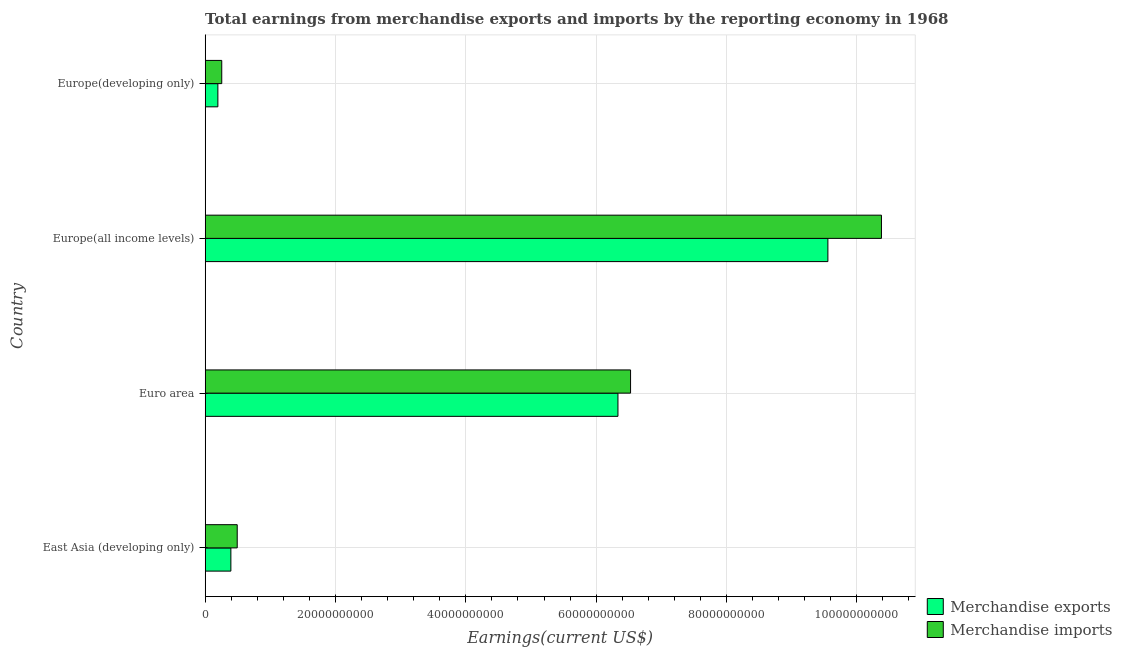Are the number of bars per tick equal to the number of legend labels?
Your answer should be very brief. Yes. Are the number of bars on each tick of the Y-axis equal?
Make the answer very short. Yes. How many bars are there on the 1st tick from the top?
Your answer should be compact. 2. What is the label of the 1st group of bars from the top?
Give a very brief answer. Europe(developing only). What is the earnings from merchandise imports in Euro area?
Offer a very short reply. 6.53e+1. Across all countries, what is the maximum earnings from merchandise exports?
Provide a succinct answer. 9.56e+1. Across all countries, what is the minimum earnings from merchandise imports?
Offer a terse response. 2.54e+09. In which country was the earnings from merchandise exports maximum?
Offer a terse response. Europe(all income levels). In which country was the earnings from merchandise exports minimum?
Your answer should be compact. Europe(developing only). What is the total earnings from merchandise imports in the graph?
Offer a very short reply. 1.77e+11. What is the difference between the earnings from merchandise exports in East Asia (developing only) and that in Europe(all income levels)?
Your answer should be very brief. -9.16e+1. What is the difference between the earnings from merchandise imports in Europe(developing only) and the earnings from merchandise exports in East Asia (developing only)?
Your answer should be compact. -1.40e+09. What is the average earnings from merchandise imports per country?
Keep it short and to the point. 4.41e+1. What is the difference between the earnings from merchandise imports and earnings from merchandise exports in Europe(all income levels)?
Provide a short and direct response. 8.22e+09. In how many countries, is the earnings from merchandise exports greater than 32000000000 US$?
Ensure brevity in your answer.  2. What is the ratio of the earnings from merchandise imports in Euro area to that in Europe(all income levels)?
Provide a short and direct response. 0.63. Is the difference between the earnings from merchandise imports in East Asia (developing only) and Europe(all income levels) greater than the difference between the earnings from merchandise exports in East Asia (developing only) and Europe(all income levels)?
Keep it short and to the point. No. What is the difference between the highest and the second highest earnings from merchandise exports?
Give a very brief answer. 3.22e+1. What is the difference between the highest and the lowest earnings from merchandise exports?
Your answer should be compact. 9.36e+1. Is the sum of the earnings from merchandise exports in Euro area and Europe(developing only) greater than the maximum earnings from merchandise imports across all countries?
Offer a terse response. No. How many bars are there?
Give a very brief answer. 8. Are all the bars in the graph horizontal?
Offer a terse response. Yes. How many legend labels are there?
Offer a terse response. 2. What is the title of the graph?
Keep it short and to the point. Total earnings from merchandise exports and imports by the reporting economy in 1968. Does "Grants" appear as one of the legend labels in the graph?
Ensure brevity in your answer.  No. What is the label or title of the X-axis?
Ensure brevity in your answer.  Earnings(current US$). What is the label or title of the Y-axis?
Make the answer very short. Country. What is the Earnings(current US$) in Merchandise exports in East Asia (developing only)?
Your response must be concise. 3.94e+09. What is the Earnings(current US$) of Merchandise imports in East Asia (developing only)?
Keep it short and to the point. 4.91e+09. What is the Earnings(current US$) in Merchandise exports in Euro area?
Ensure brevity in your answer.  6.33e+1. What is the Earnings(current US$) of Merchandise imports in Euro area?
Provide a succinct answer. 6.53e+1. What is the Earnings(current US$) in Merchandise exports in Europe(all income levels)?
Your answer should be compact. 9.56e+1. What is the Earnings(current US$) in Merchandise imports in Europe(all income levels)?
Your response must be concise. 1.04e+11. What is the Earnings(current US$) of Merchandise exports in Europe(developing only)?
Offer a very short reply. 1.95e+09. What is the Earnings(current US$) of Merchandise imports in Europe(developing only)?
Give a very brief answer. 2.54e+09. Across all countries, what is the maximum Earnings(current US$) in Merchandise exports?
Ensure brevity in your answer.  9.56e+1. Across all countries, what is the maximum Earnings(current US$) of Merchandise imports?
Your answer should be very brief. 1.04e+11. Across all countries, what is the minimum Earnings(current US$) of Merchandise exports?
Provide a succinct answer. 1.95e+09. Across all countries, what is the minimum Earnings(current US$) in Merchandise imports?
Offer a terse response. 2.54e+09. What is the total Earnings(current US$) of Merchandise exports in the graph?
Give a very brief answer. 1.65e+11. What is the total Earnings(current US$) of Merchandise imports in the graph?
Provide a short and direct response. 1.77e+11. What is the difference between the Earnings(current US$) in Merchandise exports in East Asia (developing only) and that in Euro area?
Make the answer very short. -5.94e+1. What is the difference between the Earnings(current US$) of Merchandise imports in East Asia (developing only) and that in Euro area?
Offer a terse response. -6.04e+1. What is the difference between the Earnings(current US$) of Merchandise exports in East Asia (developing only) and that in Europe(all income levels)?
Provide a short and direct response. -9.16e+1. What is the difference between the Earnings(current US$) in Merchandise imports in East Asia (developing only) and that in Europe(all income levels)?
Your answer should be compact. -9.89e+1. What is the difference between the Earnings(current US$) in Merchandise exports in East Asia (developing only) and that in Europe(developing only)?
Offer a very short reply. 1.99e+09. What is the difference between the Earnings(current US$) of Merchandise imports in East Asia (developing only) and that in Europe(developing only)?
Offer a very short reply. 2.37e+09. What is the difference between the Earnings(current US$) in Merchandise exports in Euro area and that in Europe(all income levels)?
Give a very brief answer. -3.22e+1. What is the difference between the Earnings(current US$) in Merchandise imports in Euro area and that in Europe(all income levels)?
Make the answer very short. -3.85e+1. What is the difference between the Earnings(current US$) in Merchandise exports in Euro area and that in Europe(developing only)?
Your answer should be compact. 6.14e+1. What is the difference between the Earnings(current US$) in Merchandise imports in Euro area and that in Europe(developing only)?
Offer a very short reply. 6.27e+1. What is the difference between the Earnings(current US$) of Merchandise exports in Europe(all income levels) and that in Europe(developing only)?
Keep it short and to the point. 9.36e+1. What is the difference between the Earnings(current US$) in Merchandise imports in Europe(all income levels) and that in Europe(developing only)?
Your response must be concise. 1.01e+11. What is the difference between the Earnings(current US$) of Merchandise exports in East Asia (developing only) and the Earnings(current US$) of Merchandise imports in Euro area?
Provide a succinct answer. -6.13e+1. What is the difference between the Earnings(current US$) of Merchandise exports in East Asia (developing only) and the Earnings(current US$) of Merchandise imports in Europe(all income levels)?
Your answer should be compact. -9.98e+1. What is the difference between the Earnings(current US$) in Merchandise exports in East Asia (developing only) and the Earnings(current US$) in Merchandise imports in Europe(developing only)?
Give a very brief answer. 1.40e+09. What is the difference between the Earnings(current US$) of Merchandise exports in Euro area and the Earnings(current US$) of Merchandise imports in Europe(all income levels)?
Provide a succinct answer. -4.04e+1. What is the difference between the Earnings(current US$) of Merchandise exports in Euro area and the Earnings(current US$) of Merchandise imports in Europe(developing only)?
Offer a very short reply. 6.08e+1. What is the difference between the Earnings(current US$) in Merchandise exports in Europe(all income levels) and the Earnings(current US$) in Merchandise imports in Europe(developing only)?
Your answer should be compact. 9.30e+1. What is the average Earnings(current US$) in Merchandise exports per country?
Your answer should be compact. 4.12e+1. What is the average Earnings(current US$) in Merchandise imports per country?
Make the answer very short. 4.41e+1. What is the difference between the Earnings(current US$) in Merchandise exports and Earnings(current US$) in Merchandise imports in East Asia (developing only)?
Provide a short and direct response. -9.73e+08. What is the difference between the Earnings(current US$) in Merchandise exports and Earnings(current US$) in Merchandise imports in Euro area?
Keep it short and to the point. -1.93e+09. What is the difference between the Earnings(current US$) in Merchandise exports and Earnings(current US$) in Merchandise imports in Europe(all income levels)?
Your response must be concise. -8.22e+09. What is the difference between the Earnings(current US$) in Merchandise exports and Earnings(current US$) in Merchandise imports in Europe(developing only)?
Ensure brevity in your answer.  -5.94e+08. What is the ratio of the Earnings(current US$) in Merchandise exports in East Asia (developing only) to that in Euro area?
Give a very brief answer. 0.06. What is the ratio of the Earnings(current US$) in Merchandise imports in East Asia (developing only) to that in Euro area?
Your response must be concise. 0.08. What is the ratio of the Earnings(current US$) of Merchandise exports in East Asia (developing only) to that in Europe(all income levels)?
Your answer should be very brief. 0.04. What is the ratio of the Earnings(current US$) of Merchandise imports in East Asia (developing only) to that in Europe(all income levels)?
Your answer should be compact. 0.05. What is the ratio of the Earnings(current US$) of Merchandise exports in East Asia (developing only) to that in Europe(developing only)?
Give a very brief answer. 2.02. What is the ratio of the Earnings(current US$) in Merchandise imports in East Asia (developing only) to that in Europe(developing only)?
Keep it short and to the point. 1.93. What is the ratio of the Earnings(current US$) of Merchandise exports in Euro area to that in Europe(all income levels)?
Give a very brief answer. 0.66. What is the ratio of the Earnings(current US$) in Merchandise imports in Euro area to that in Europe(all income levels)?
Your response must be concise. 0.63. What is the ratio of the Earnings(current US$) of Merchandise exports in Euro area to that in Europe(developing only)?
Your response must be concise. 32.54. What is the ratio of the Earnings(current US$) of Merchandise imports in Euro area to that in Europe(developing only)?
Your answer should be compact. 25.69. What is the ratio of the Earnings(current US$) in Merchandise exports in Europe(all income levels) to that in Europe(developing only)?
Your response must be concise. 49.08. What is the ratio of the Earnings(current US$) in Merchandise imports in Europe(all income levels) to that in Europe(developing only)?
Make the answer very short. 40.85. What is the difference between the highest and the second highest Earnings(current US$) in Merchandise exports?
Make the answer very short. 3.22e+1. What is the difference between the highest and the second highest Earnings(current US$) in Merchandise imports?
Provide a succinct answer. 3.85e+1. What is the difference between the highest and the lowest Earnings(current US$) in Merchandise exports?
Offer a very short reply. 9.36e+1. What is the difference between the highest and the lowest Earnings(current US$) of Merchandise imports?
Offer a terse response. 1.01e+11. 